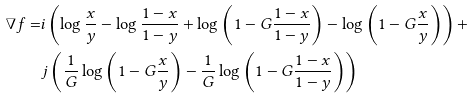Convert formula to latex. <formula><loc_0><loc_0><loc_500><loc_500>\nabla f = & i \left ( \log \frac { x } { y } - \log \frac { 1 - x } { 1 - y } + \log \left ( 1 - G \frac { 1 - x } { 1 - y } \right ) - \log \left ( 1 - G \frac { x } { y } \right ) \right ) + \\ & j \left ( \frac { 1 } { G } \log \left ( 1 - G \frac { x } { y } \right ) - \frac { 1 } { G } \log \left ( 1 - G \frac { 1 - x } { 1 - y } \right ) \right )</formula> 